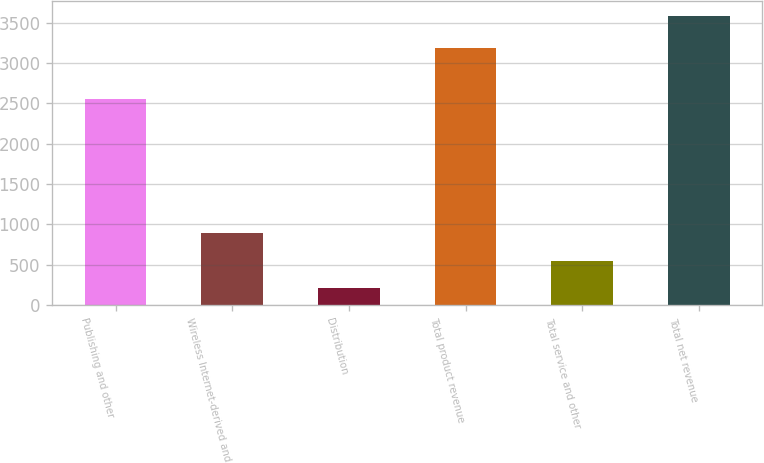Convert chart to OTSL. <chart><loc_0><loc_0><loc_500><loc_500><bar_chart><fcel>Publishing and other<fcel>Wireless Internet-derived and<fcel>Distribution<fcel>Total product revenue<fcel>Total service and other<fcel>Total net revenue<nl><fcel>2558<fcel>889<fcel>214<fcel>3181<fcel>551.5<fcel>3589<nl></chart> 